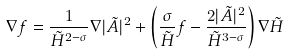<formula> <loc_0><loc_0><loc_500><loc_500>\nabla f = \frac { 1 } { \tilde { H } ^ { 2 - \sigma } } \nabla | \tilde { A } | ^ { 2 } + \left ( \frac { \sigma } { \tilde { H } } f - \frac { 2 | \tilde { A } | ^ { 2 } } { \tilde { H } ^ { 3 - \sigma } } \right ) \nabla \tilde { H }</formula> 